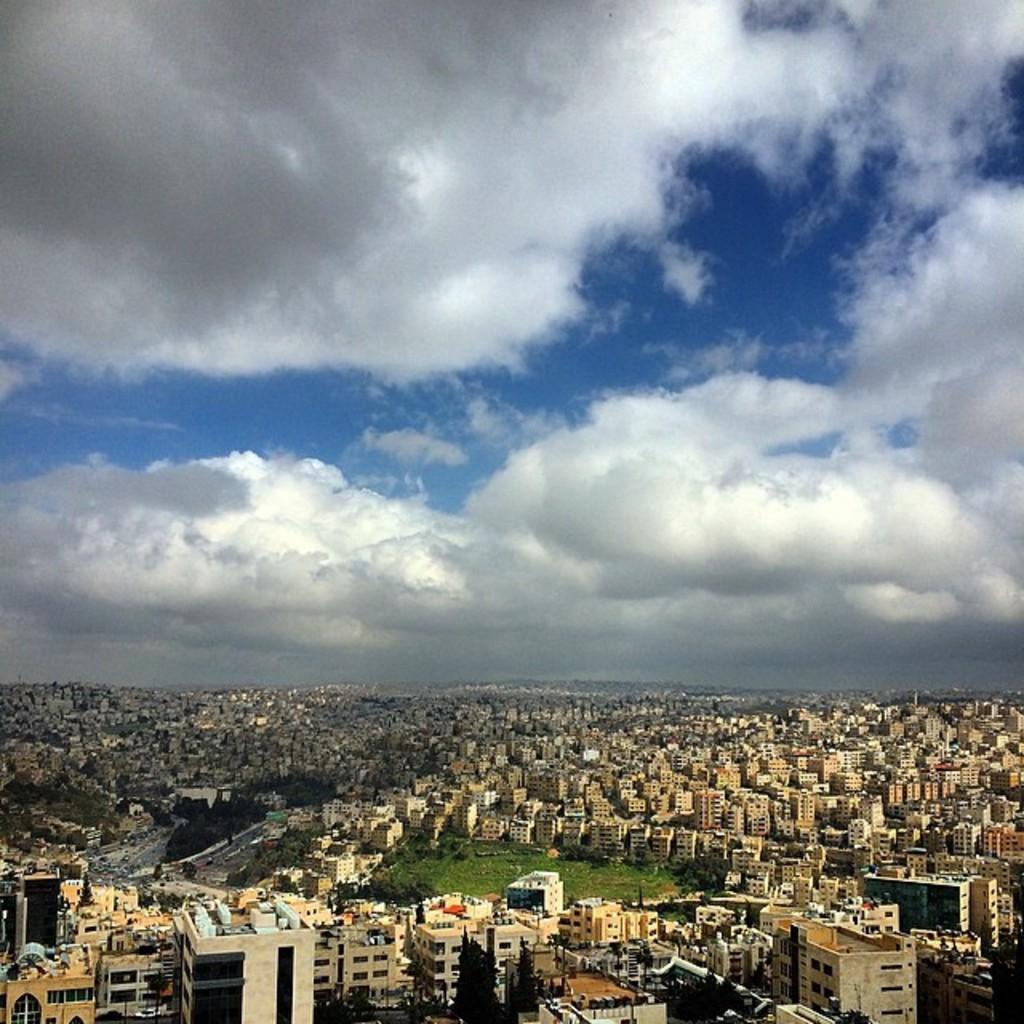Can you describe this image briefly? In this picture there are many buildings, poles, and trees at the bottom side of the image and there is sky at the top side of the image. 